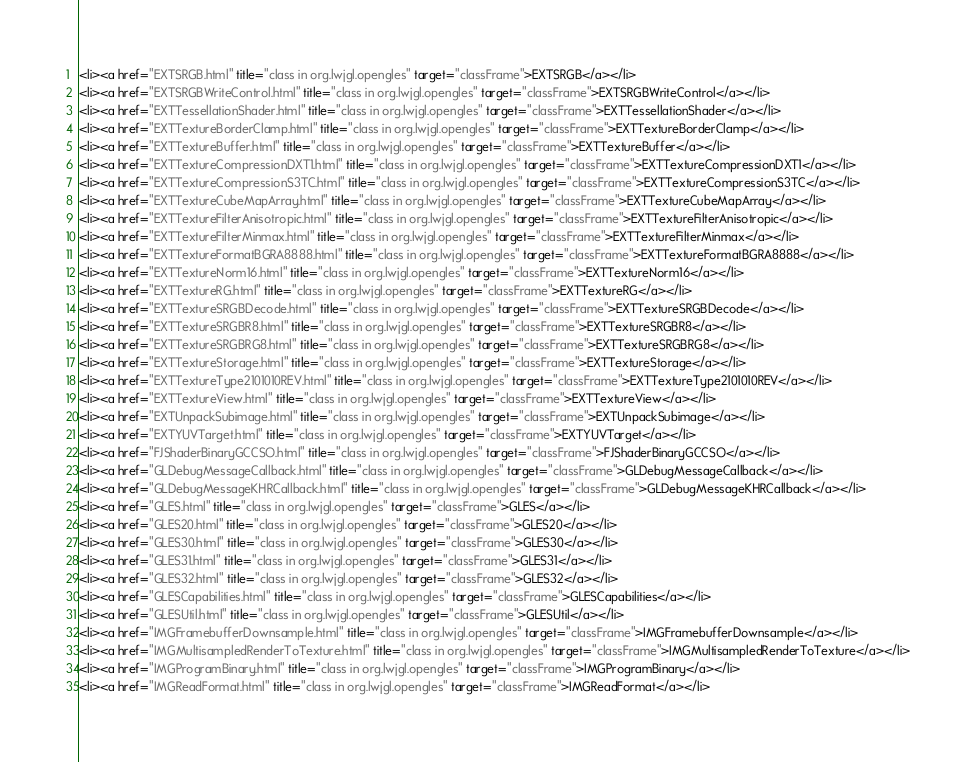Convert code to text. <code><loc_0><loc_0><loc_500><loc_500><_HTML_><li><a href="EXTSRGB.html" title="class in org.lwjgl.opengles" target="classFrame">EXTSRGB</a></li>
<li><a href="EXTSRGBWriteControl.html" title="class in org.lwjgl.opengles" target="classFrame">EXTSRGBWriteControl</a></li>
<li><a href="EXTTessellationShader.html" title="class in org.lwjgl.opengles" target="classFrame">EXTTessellationShader</a></li>
<li><a href="EXTTextureBorderClamp.html" title="class in org.lwjgl.opengles" target="classFrame">EXTTextureBorderClamp</a></li>
<li><a href="EXTTextureBuffer.html" title="class in org.lwjgl.opengles" target="classFrame">EXTTextureBuffer</a></li>
<li><a href="EXTTextureCompressionDXT1.html" title="class in org.lwjgl.opengles" target="classFrame">EXTTextureCompressionDXT1</a></li>
<li><a href="EXTTextureCompressionS3TC.html" title="class in org.lwjgl.opengles" target="classFrame">EXTTextureCompressionS3TC</a></li>
<li><a href="EXTTextureCubeMapArray.html" title="class in org.lwjgl.opengles" target="classFrame">EXTTextureCubeMapArray</a></li>
<li><a href="EXTTextureFilterAnisotropic.html" title="class in org.lwjgl.opengles" target="classFrame">EXTTextureFilterAnisotropic</a></li>
<li><a href="EXTTextureFilterMinmax.html" title="class in org.lwjgl.opengles" target="classFrame">EXTTextureFilterMinmax</a></li>
<li><a href="EXTTextureFormatBGRA8888.html" title="class in org.lwjgl.opengles" target="classFrame">EXTTextureFormatBGRA8888</a></li>
<li><a href="EXTTextureNorm16.html" title="class in org.lwjgl.opengles" target="classFrame">EXTTextureNorm16</a></li>
<li><a href="EXTTextureRG.html" title="class in org.lwjgl.opengles" target="classFrame">EXTTextureRG</a></li>
<li><a href="EXTTextureSRGBDecode.html" title="class in org.lwjgl.opengles" target="classFrame">EXTTextureSRGBDecode</a></li>
<li><a href="EXTTextureSRGBR8.html" title="class in org.lwjgl.opengles" target="classFrame">EXTTextureSRGBR8</a></li>
<li><a href="EXTTextureSRGBRG8.html" title="class in org.lwjgl.opengles" target="classFrame">EXTTextureSRGBRG8</a></li>
<li><a href="EXTTextureStorage.html" title="class in org.lwjgl.opengles" target="classFrame">EXTTextureStorage</a></li>
<li><a href="EXTTextureType2101010REV.html" title="class in org.lwjgl.opengles" target="classFrame">EXTTextureType2101010REV</a></li>
<li><a href="EXTTextureView.html" title="class in org.lwjgl.opengles" target="classFrame">EXTTextureView</a></li>
<li><a href="EXTUnpackSubimage.html" title="class in org.lwjgl.opengles" target="classFrame">EXTUnpackSubimage</a></li>
<li><a href="EXTYUVTarget.html" title="class in org.lwjgl.opengles" target="classFrame">EXTYUVTarget</a></li>
<li><a href="FJShaderBinaryGCCSO.html" title="class in org.lwjgl.opengles" target="classFrame">FJShaderBinaryGCCSO</a></li>
<li><a href="GLDebugMessageCallback.html" title="class in org.lwjgl.opengles" target="classFrame">GLDebugMessageCallback</a></li>
<li><a href="GLDebugMessageKHRCallback.html" title="class in org.lwjgl.opengles" target="classFrame">GLDebugMessageKHRCallback</a></li>
<li><a href="GLES.html" title="class in org.lwjgl.opengles" target="classFrame">GLES</a></li>
<li><a href="GLES20.html" title="class in org.lwjgl.opengles" target="classFrame">GLES20</a></li>
<li><a href="GLES30.html" title="class in org.lwjgl.opengles" target="classFrame">GLES30</a></li>
<li><a href="GLES31.html" title="class in org.lwjgl.opengles" target="classFrame">GLES31</a></li>
<li><a href="GLES32.html" title="class in org.lwjgl.opengles" target="classFrame">GLES32</a></li>
<li><a href="GLESCapabilities.html" title="class in org.lwjgl.opengles" target="classFrame">GLESCapabilities</a></li>
<li><a href="GLESUtil.html" title="class in org.lwjgl.opengles" target="classFrame">GLESUtil</a></li>
<li><a href="IMGFramebufferDownsample.html" title="class in org.lwjgl.opengles" target="classFrame">IMGFramebufferDownsample</a></li>
<li><a href="IMGMultisampledRenderToTexture.html" title="class in org.lwjgl.opengles" target="classFrame">IMGMultisampledRenderToTexture</a></li>
<li><a href="IMGProgramBinary.html" title="class in org.lwjgl.opengles" target="classFrame">IMGProgramBinary</a></li>
<li><a href="IMGReadFormat.html" title="class in org.lwjgl.opengles" target="classFrame">IMGReadFormat</a></li></code> 